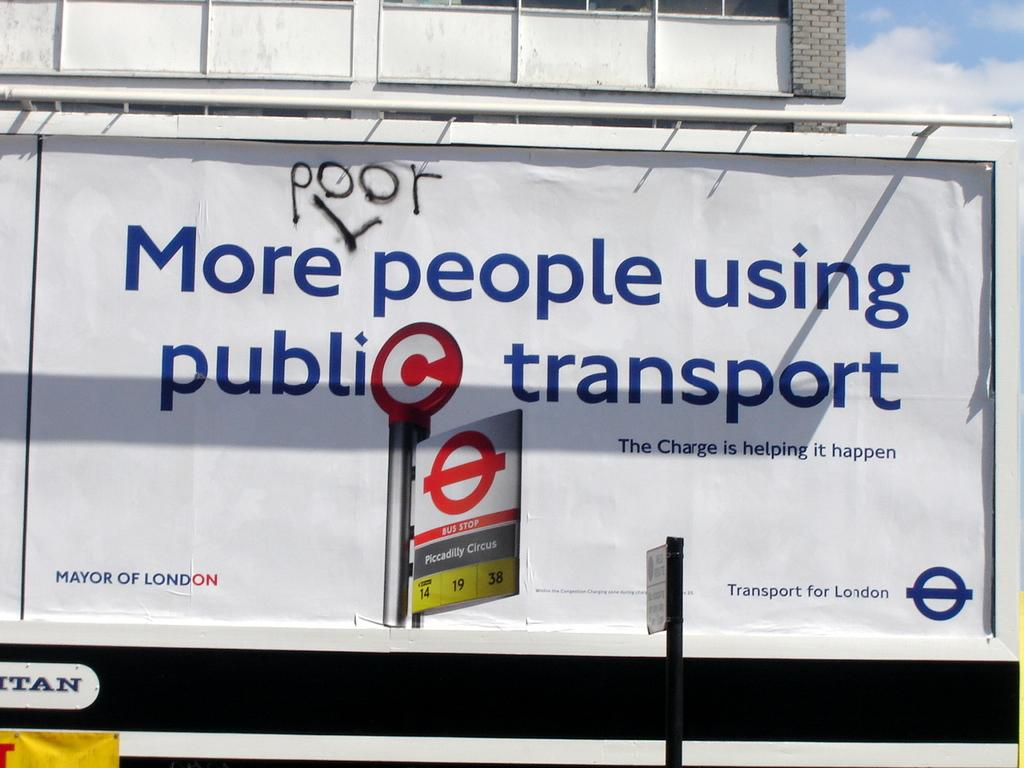Provide a one-sentence caption for the provided image. A sign advertising public transport, but someone has written the word "poor" over it. 